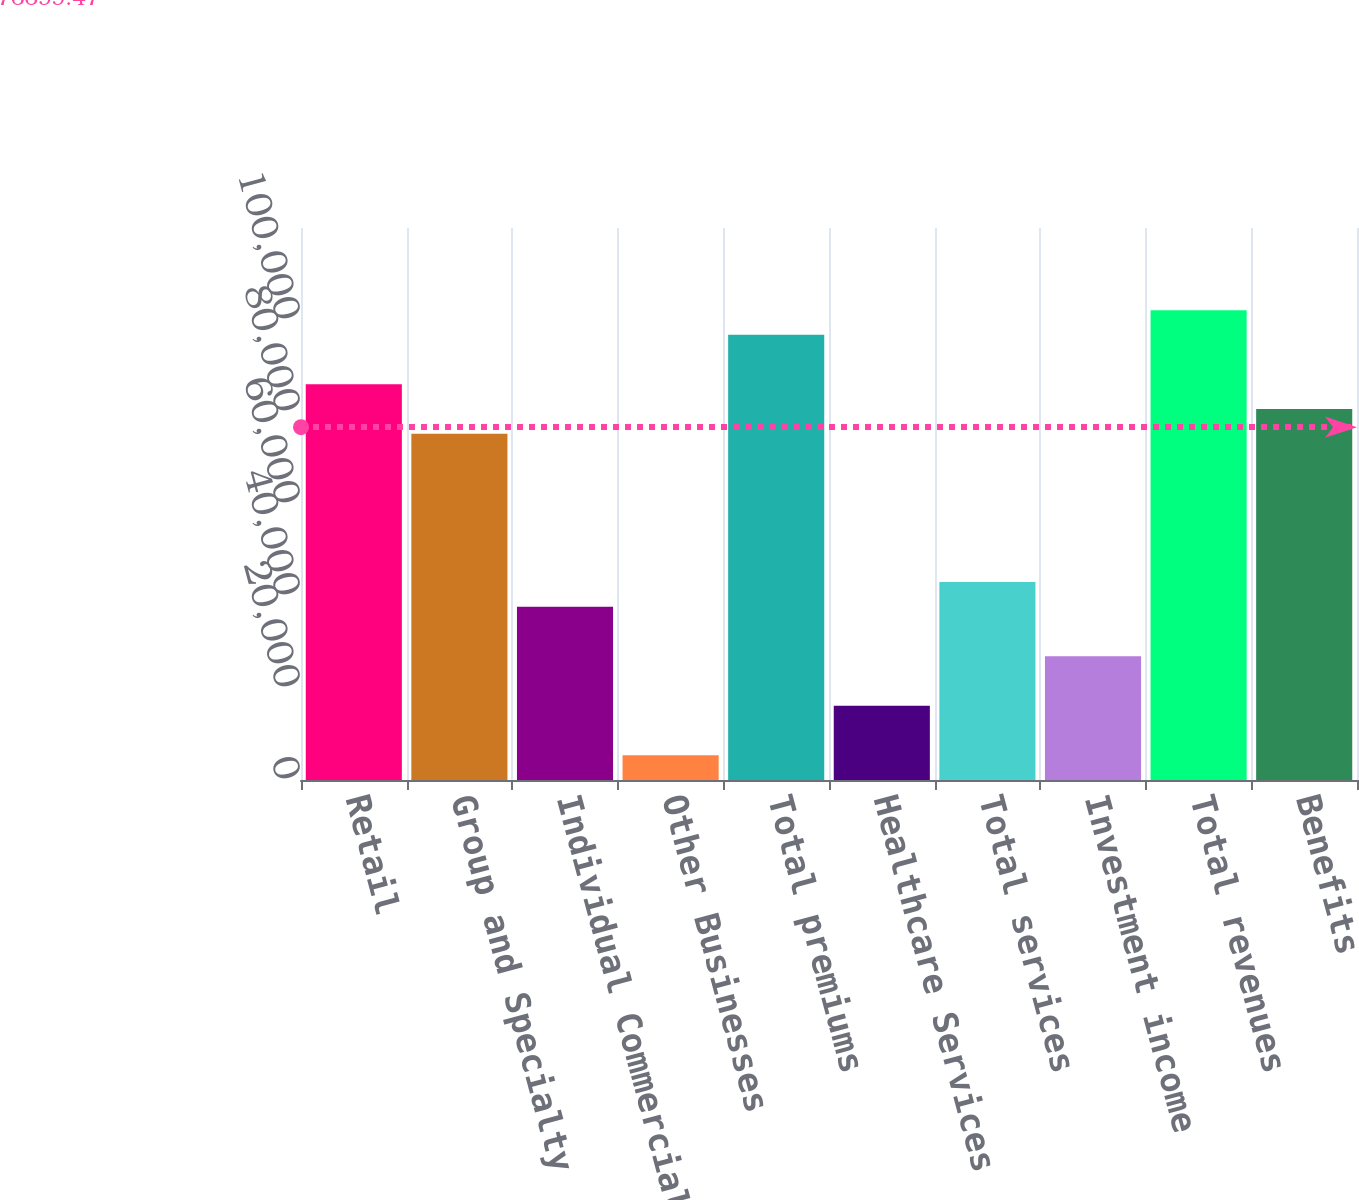Convert chart to OTSL. <chart><loc_0><loc_0><loc_500><loc_500><bar_chart><fcel>Retail<fcel>Group and Specialty<fcel>Individual Commercial<fcel>Other Businesses<fcel>Total premiums<fcel>Healthcare Services<fcel>Total services<fcel>Investment income<fcel>Total revenues<fcel>Benefits<nl><fcel>86017.1<fcel>75267.1<fcel>37641.9<fcel>5391.83<fcel>96767.2<fcel>16141.9<fcel>43017<fcel>26891.9<fcel>102142<fcel>80642.1<nl></chart> 